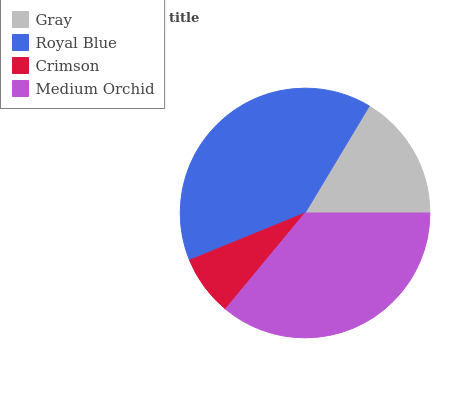Is Crimson the minimum?
Answer yes or no. Yes. Is Royal Blue the maximum?
Answer yes or no. Yes. Is Royal Blue the minimum?
Answer yes or no. No. Is Crimson the maximum?
Answer yes or no. No. Is Royal Blue greater than Crimson?
Answer yes or no. Yes. Is Crimson less than Royal Blue?
Answer yes or no. Yes. Is Crimson greater than Royal Blue?
Answer yes or no. No. Is Royal Blue less than Crimson?
Answer yes or no. No. Is Medium Orchid the high median?
Answer yes or no. Yes. Is Gray the low median?
Answer yes or no. Yes. Is Royal Blue the high median?
Answer yes or no. No. Is Royal Blue the low median?
Answer yes or no. No. 